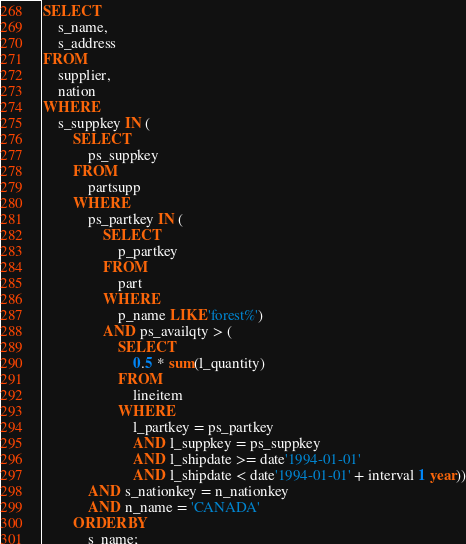Convert code to text. <code><loc_0><loc_0><loc_500><loc_500><_SQL_>SELECT
    s_name,
    s_address
FROM
    supplier,
    nation
WHERE
    s_suppkey IN (
        SELECT
            ps_suppkey
        FROM
            partsupp
        WHERE
            ps_partkey IN (
                SELECT
                    p_partkey
                FROM
                    part
                WHERE
                    p_name LIKE 'forest%')
                AND ps_availqty > (
                    SELECT
                        0.5 * sum(l_quantity)
                    FROM
                        lineitem
                    WHERE
                        l_partkey = ps_partkey
                        AND l_suppkey = ps_suppkey
                        AND l_shipdate >= date'1994-01-01'
                        AND l_shipdate < date'1994-01-01' + interval 1 year))
            AND s_nationkey = n_nationkey
            AND n_name = 'CANADA'
        ORDER BY
            s_name;
</code> 